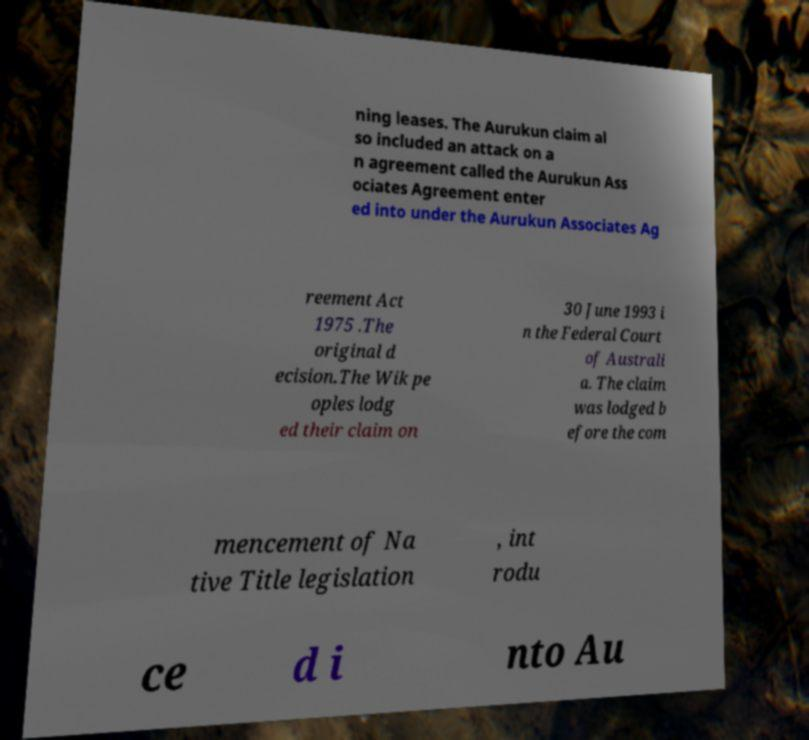Could you extract and type out the text from this image? ning leases. The Aurukun claim al so included an attack on a n agreement called the Aurukun Ass ociates Agreement enter ed into under the Aurukun Associates Ag reement Act 1975 .The original d ecision.The Wik pe oples lodg ed their claim on 30 June 1993 i n the Federal Court of Australi a. The claim was lodged b efore the com mencement of Na tive Title legislation , int rodu ce d i nto Au 